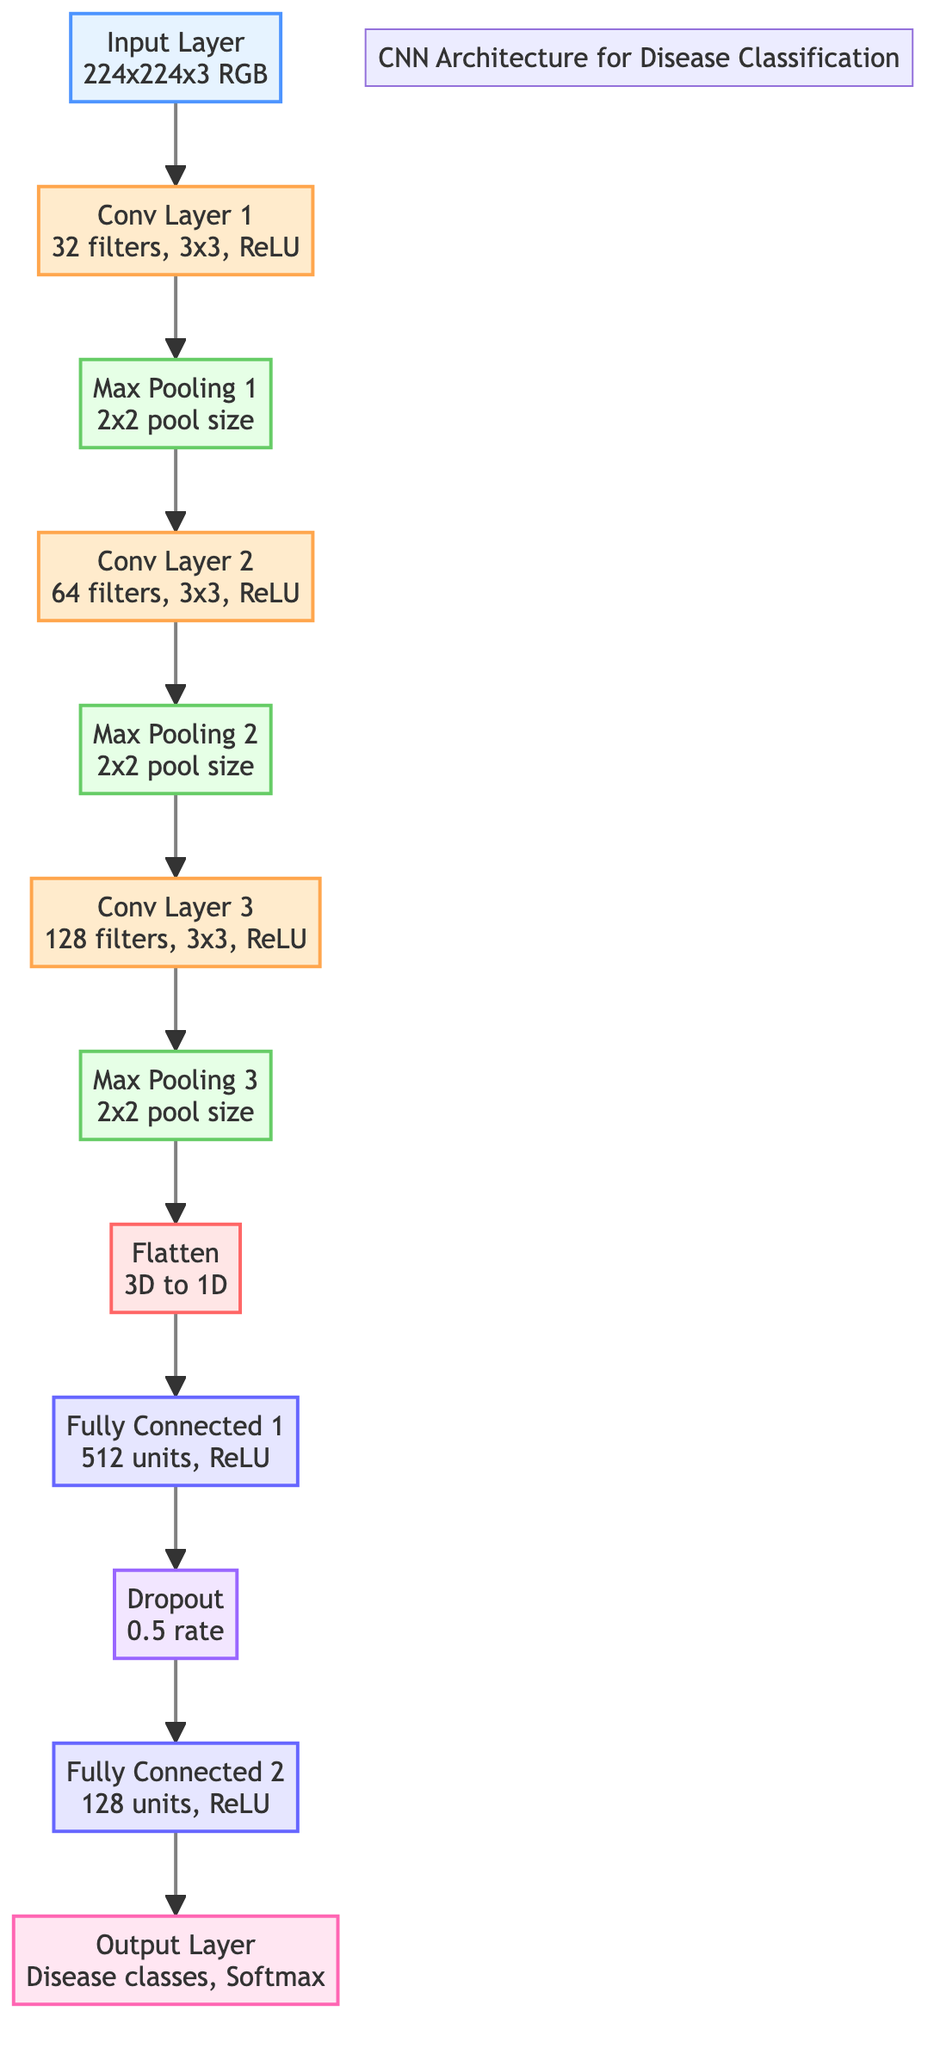What is the size of the input layer? The input layer is labeled with the dimensions "224x224x3 RGB," indicating the height and width of the image, as well as the number of color channels.
Answer: 224x224x3 RGB How many filters are used in Conv Layer 1? Conv Layer 1 has "32 filters" explicitly mentioned in the diagram, indicating the number of convolution operations performed at this layer.
Answer: 32 What is the pooling size used in Max Pooling 1? The Max Pooling 1 node specifies a "2x2 pool size," indicating the dimensions of the pooling window that will be applied to the feature maps.
Answer: 2x2 How many units are present in Fully Connected 1? Fully Connected 1 is mentioned as having "512 units," which indicates the number of neurons in this layer that contribute to the output.
Answer: 512 What activation function is applied in Conv Layer 2? The diagram states "ReLU" as the activation function for Conv Layer 2, indicating that it uses the Rectified Linear Unit for activation.
Answer: ReLU What layer comes after Flatten? The Flatten layer feeds into Fully Connected 1, which is specified in the diagram to show the next step in the architecture after converting the 3D data to 1D.
Answer: Fully Connected 1 What is the dropout rate in the Dropout layer? The Dropout layer is labeled with a "0.5 rate," indicating that 50% of the neurons will be ignored during training to prevent overfitting.
Answer: 0.5 How many convolutional layers are present in this architecture? The diagram illustrates three convolutional layers, explicitly labeled as Conv Layer 1, Conv Layer 2, and Conv Layer 3.
Answer: 3 Which layer is responsible for the final classification of diseases? The Output Layer is indicated as being responsible for the final classification of disease classes with a Softmax activation function.
Answer: Output Layer 